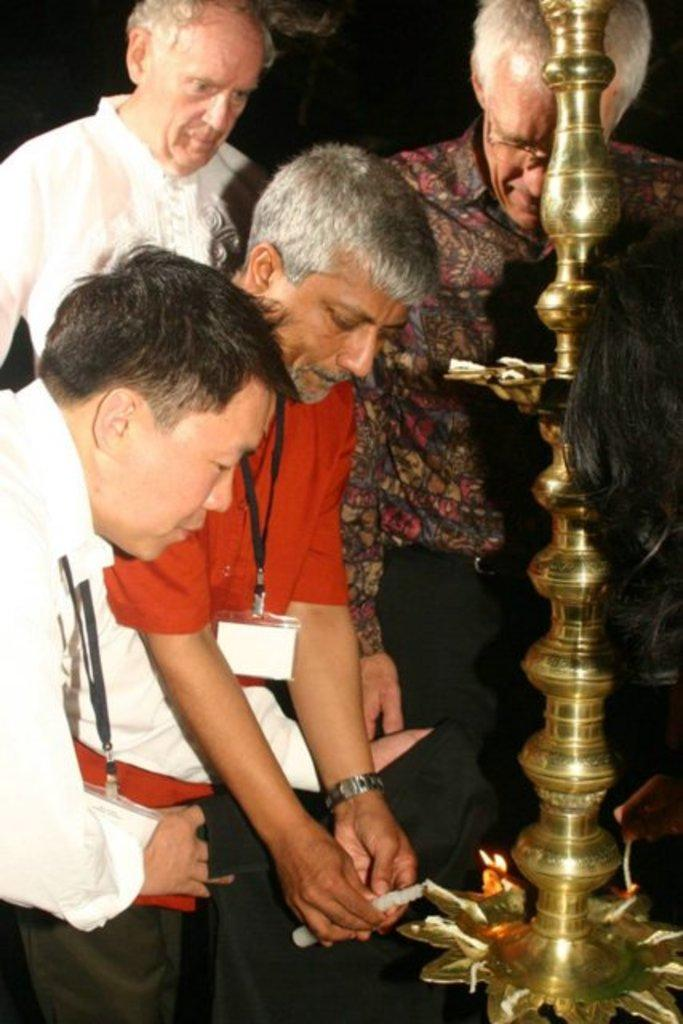What is happening in the image? There are people standing near a stand in the image. Can you describe the activity of one of the people? A person is holding a candle in the image. What type of cabbage is being used to light the candles in the image? There is no cabbage present in the image; a person is holding a candle. How many rings can be seen on the person holding the candle in the image? There is no mention of rings in the image; a person is holding a candle. 